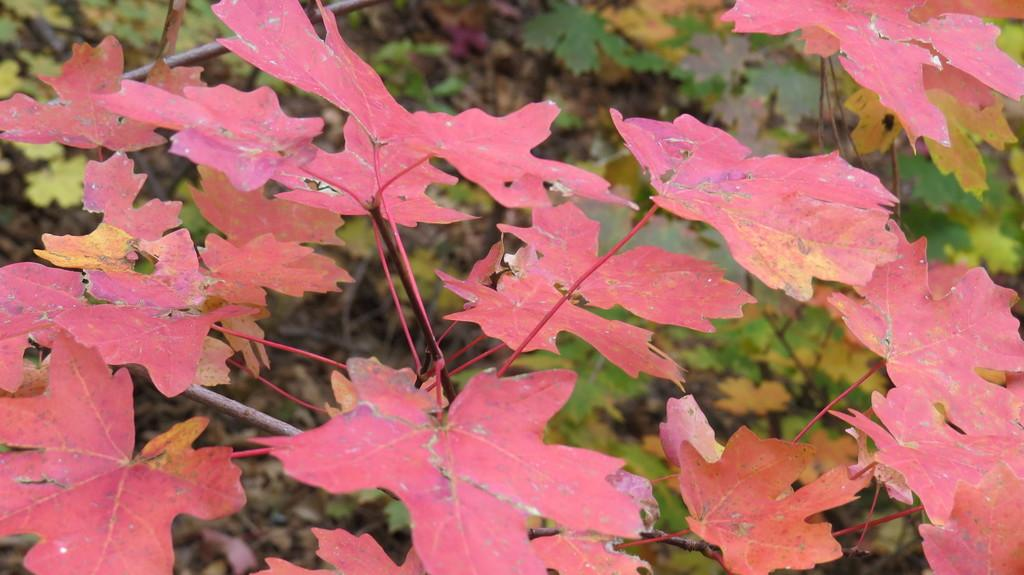What is in the foreground of the picture? There are leaves of a tree in the foreground of the picture. How would you describe the background of the image? The background of the image is blurred. Can you identify any other trees in the image? Yes, there is a tree in the background of the picture. What type of competition is taking place in the image? There is no competition present in the image; it features leaves of a tree in the foreground and a blurred background. Can you provide an example of a similar image? The provided facts do not allow for an example of a similar image to be given. 